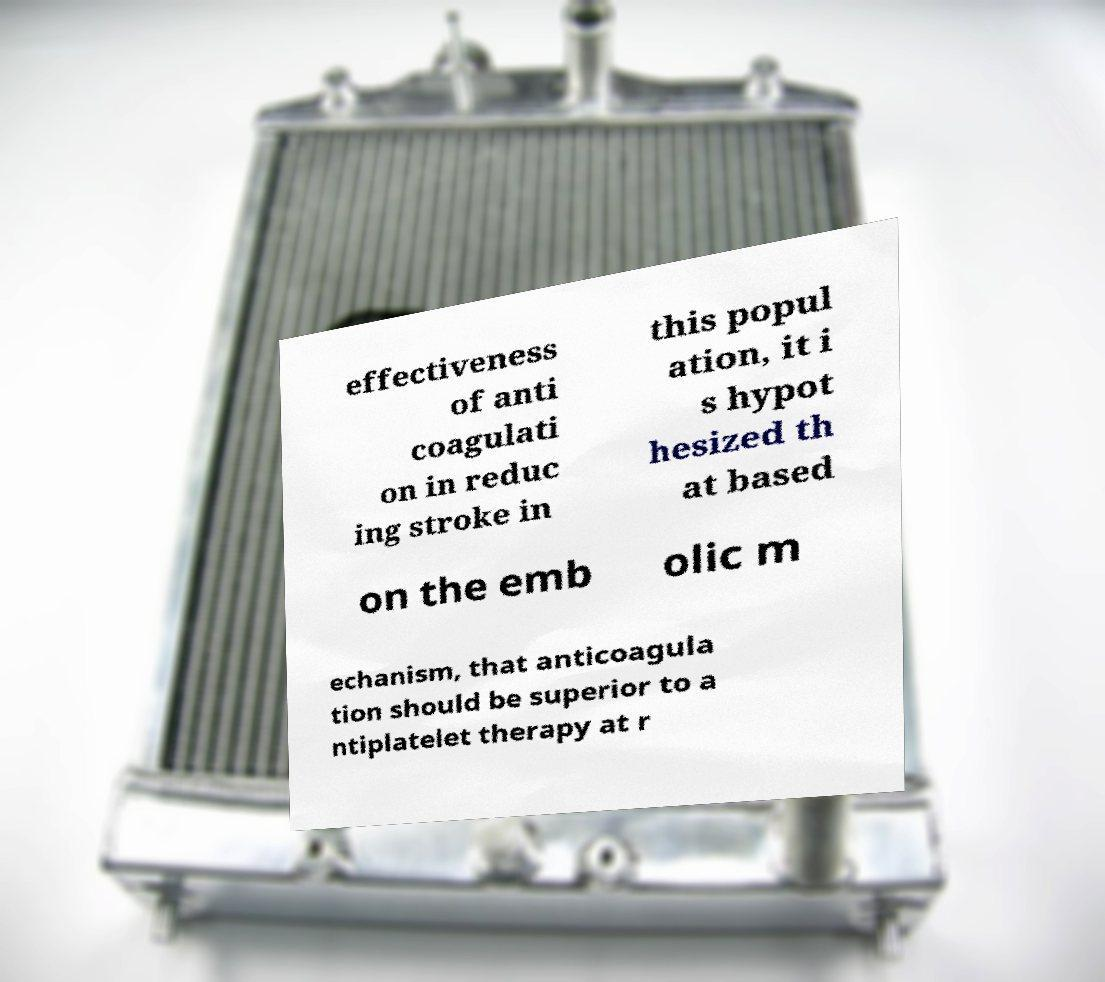Can you read and provide the text displayed in the image?This photo seems to have some interesting text. Can you extract and type it out for me? effectiveness of anti coagulati on in reduc ing stroke in this popul ation, it i s hypot hesized th at based on the emb olic m echanism, that anticoagula tion should be superior to a ntiplatelet therapy at r 